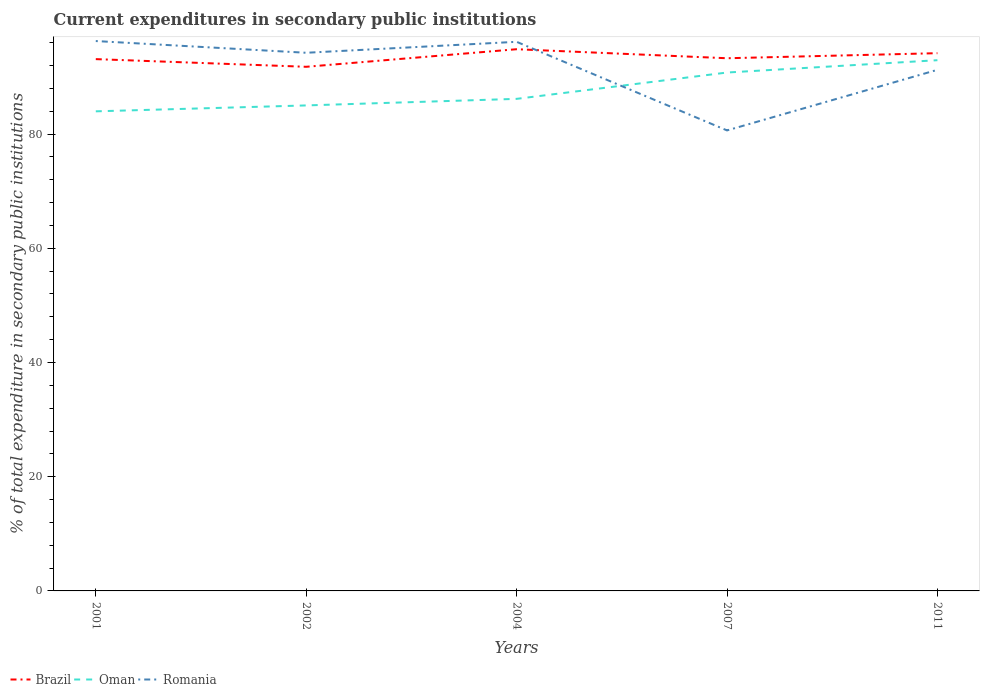How many different coloured lines are there?
Offer a very short reply. 3. Does the line corresponding to Romania intersect with the line corresponding to Brazil?
Your answer should be compact. Yes. Is the number of lines equal to the number of legend labels?
Keep it short and to the point. Yes. Across all years, what is the maximum current expenditures in secondary public institutions in Brazil?
Your answer should be very brief. 91.79. In which year was the current expenditures in secondary public institutions in Romania maximum?
Provide a short and direct response. 2007. What is the total current expenditures in secondary public institutions in Oman in the graph?
Provide a short and direct response. -1.03. What is the difference between the highest and the second highest current expenditures in secondary public institutions in Oman?
Offer a terse response. 8.96. What is the difference between the highest and the lowest current expenditures in secondary public institutions in Brazil?
Make the answer very short. 2. Is the current expenditures in secondary public institutions in Romania strictly greater than the current expenditures in secondary public institutions in Brazil over the years?
Keep it short and to the point. No. How many lines are there?
Offer a terse response. 3. How many years are there in the graph?
Keep it short and to the point. 5. Are the values on the major ticks of Y-axis written in scientific E-notation?
Keep it short and to the point. No. Where does the legend appear in the graph?
Keep it short and to the point. Bottom left. How are the legend labels stacked?
Provide a short and direct response. Horizontal. What is the title of the graph?
Make the answer very short. Current expenditures in secondary public institutions. Does "Guyana" appear as one of the legend labels in the graph?
Keep it short and to the point. No. What is the label or title of the Y-axis?
Your response must be concise. % of total expenditure in secondary public institutions. What is the % of total expenditure in secondary public institutions of Brazil in 2001?
Make the answer very short. 93.13. What is the % of total expenditure in secondary public institutions in Oman in 2001?
Provide a short and direct response. 83.99. What is the % of total expenditure in secondary public institutions of Romania in 2001?
Your answer should be compact. 96.3. What is the % of total expenditure in secondary public institutions in Brazil in 2002?
Provide a short and direct response. 91.79. What is the % of total expenditure in secondary public institutions in Oman in 2002?
Give a very brief answer. 85.02. What is the % of total expenditure in secondary public institutions of Romania in 2002?
Your response must be concise. 94.24. What is the % of total expenditure in secondary public institutions of Brazil in 2004?
Provide a short and direct response. 94.86. What is the % of total expenditure in secondary public institutions in Oman in 2004?
Provide a short and direct response. 86.17. What is the % of total expenditure in secondary public institutions in Romania in 2004?
Your response must be concise. 96.16. What is the % of total expenditure in secondary public institutions in Brazil in 2007?
Your response must be concise. 93.28. What is the % of total expenditure in secondary public institutions of Oman in 2007?
Offer a terse response. 90.78. What is the % of total expenditure in secondary public institutions in Romania in 2007?
Give a very brief answer. 80.65. What is the % of total expenditure in secondary public institutions in Brazil in 2011?
Keep it short and to the point. 94.17. What is the % of total expenditure in secondary public institutions of Oman in 2011?
Your answer should be compact. 92.94. What is the % of total expenditure in secondary public institutions in Romania in 2011?
Offer a terse response. 91.26. Across all years, what is the maximum % of total expenditure in secondary public institutions of Brazil?
Give a very brief answer. 94.86. Across all years, what is the maximum % of total expenditure in secondary public institutions in Oman?
Offer a terse response. 92.94. Across all years, what is the maximum % of total expenditure in secondary public institutions of Romania?
Your answer should be compact. 96.3. Across all years, what is the minimum % of total expenditure in secondary public institutions of Brazil?
Your answer should be very brief. 91.79. Across all years, what is the minimum % of total expenditure in secondary public institutions of Oman?
Offer a very short reply. 83.99. Across all years, what is the minimum % of total expenditure in secondary public institutions in Romania?
Ensure brevity in your answer.  80.65. What is the total % of total expenditure in secondary public institutions of Brazil in the graph?
Offer a terse response. 467.24. What is the total % of total expenditure in secondary public institutions of Oman in the graph?
Provide a short and direct response. 438.91. What is the total % of total expenditure in secondary public institutions of Romania in the graph?
Ensure brevity in your answer.  458.6. What is the difference between the % of total expenditure in secondary public institutions in Brazil in 2001 and that in 2002?
Provide a short and direct response. 1.34. What is the difference between the % of total expenditure in secondary public institutions in Oman in 2001 and that in 2002?
Keep it short and to the point. -1.03. What is the difference between the % of total expenditure in secondary public institutions in Romania in 2001 and that in 2002?
Keep it short and to the point. 2.05. What is the difference between the % of total expenditure in secondary public institutions of Brazil in 2001 and that in 2004?
Offer a terse response. -1.73. What is the difference between the % of total expenditure in secondary public institutions in Oman in 2001 and that in 2004?
Your response must be concise. -2.19. What is the difference between the % of total expenditure in secondary public institutions of Romania in 2001 and that in 2004?
Your answer should be compact. 0.13. What is the difference between the % of total expenditure in secondary public institutions of Brazil in 2001 and that in 2007?
Make the answer very short. -0.15. What is the difference between the % of total expenditure in secondary public institutions of Oman in 2001 and that in 2007?
Your response must be concise. -6.8. What is the difference between the % of total expenditure in secondary public institutions of Romania in 2001 and that in 2007?
Your response must be concise. 15.65. What is the difference between the % of total expenditure in secondary public institutions in Brazil in 2001 and that in 2011?
Your answer should be compact. -1.04. What is the difference between the % of total expenditure in secondary public institutions in Oman in 2001 and that in 2011?
Offer a terse response. -8.96. What is the difference between the % of total expenditure in secondary public institutions in Romania in 2001 and that in 2011?
Provide a short and direct response. 5.04. What is the difference between the % of total expenditure in secondary public institutions in Brazil in 2002 and that in 2004?
Offer a very short reply. -3.08. What is the difference between the % of total expenditure in secondary public institutions of Oman in 2002 and that in 2004?
Offer a very short reply. -1.15. What is the difference between the % of total expenditure in secondary public institutions in Romania in 2002 and that in 2004?
Your answer should be compact. -1.92. What is the difference between the % of total expenditure in secondary public institutions of Brazil in 2002 and that in 2007?
Give a very brief answer. -1.5. What is the difference between the % of total expenditure in secondary public institutions of Oman in 2002 and that in 2007?
Keep it short and to the point. -5.76. What is the difference between the % of total expenditure in secondary public institutions in Romania in 2002 and that in 2007?
Make the answer very short. 13.6. What is the difference between the % of total expenditure in secondary public institutions of Brazil in 2002 and that in 2011?
Your response must be concise. -2.38. What is the difference between the % of total expenditure in secondary public institutions in Oman in 2002 and that in 2011?
Provide a short and direct response. -7.92. What is the difference between the % of total expenditure in secondary public institutions in Romania in 2002 and that in 2011?
Your answer should be very brief. 2.99. What is the difference between the % of total expenditure in secondary public institutions of Brazil in 2004 and that in 2007?
Offer a very short reply. 1.58. What is the difference between the % of total expenditure in secondary public institutions of Oman in 2004 and that in 2007?
Keep it short and to the point. -4.61. What is the difference between the % of total expenditure in secondary public institutions in Romania in 2004 and that in 2007?
Provide a succinct answer. 15.52. What is the difference between the % of total expenditure in secondary public institutions of Brazil in 2004 and that in 2011?
Your answer should be compact. 0.69. What is the difference between the % of total expenditure in secondary public institutions of Oman in 2004 and that in 2011?
Your response must be concise. -6.77. What is the difference between the % of total expenditure in secondary public institutions of Romania in 2004 and that in 2011?
Make the answer very short. 4.91. What is the difference between the % of total expenditure in secondary public institutions in Brazil in 2007 and that in 2011?
Offer a terse response. -0.89. What is the difference between the % of total expenditure in secondary public institutions of Oman in 2007 and that in 2011?
Keep it short and to the point. -2.16. What is the difference between the % of total expenditure in secondary public institutions in Romania in 2007 and that in 2011?
Ensure brevity in your answer.  -10.61. What is the difference between the % of total expenditure in secondary public institutions of Brazil in 2001 and the % of total expenditure in secondary public institutions of Oman in 2002?
Offer a very short reply. 8.11. What is the difference between the % of total expenditure in secondary public institutions in Brazil in 2001 and the % of total expenditure in secondary public institutions in Romania in 2002?
Give a very brief answer. -1.11. What is the difference between the % of total expenditure in secondary public institutions in Oman in 2001 and the % of total expenditure in secondary public institutions in Romania in 2002?
Make the answer very short. -10.26. What is the difference between the % of total expenditure in secondary public institutions in Brazil in 2001 and the % of total expenditure in secondary public institutions in Oman in 2004?
Provide a succinct answer. 6.96. What is the difference between the % of total expenditure in secondary public institutions in Brazil in 2001 and the % of total expenditure in secondary public institutions in Romania in 2004?
Your answer should be compact. -3.03. What is the difference between the % of total expenditure in secondary public institutions in Oman in 2001 and the % of total expenditure in secondary public institutions in Romania in 2004?
Your answer should be compact. -12.18. What is the difference between the % of total expenditure in secondary public institutions of Brazil in 2001 and the % of total expenditure in secondary public institutions of Oman in 2007?
Ensure brevity in your answer.  2.35. What is the difference between the % of total expenditure in secondary public institutions in Brazil in 2001 and the % of total expenditure in secondary public institutions in Romania in 2007?
Your answer should be compact. 12.48. What is the difference between the % of total expenditure in secondary public institutions in Oman in 2001 and the % of total expenditure in secondary public institutions in Romania in 2007?
Ensure brevity in your answer.  3.34. What is the difference between the % of total expenditure in secondary public institutions of Brazil in 2001 and the % of total expenditure in secondary public institutions of Oman in 2011?
Your response must be concise. 0.19. What is the difference between the % of total expenditure in secondary public institutions in Brazil in 2001 and the % of total expenditure in secondary public institutions in Romania in 2011?
Provide a succinct answer. 1.88. What is the difference between the % of total expenditure in secondary public institutions in Oman in 2001 and the % of total expenditure in secondary public institutions in Romania in 2011?
Ensure brevity in your answer.  -7.27. What is the difference between the % of total expenditure in secondary public institutions in Brazil in 2002 and the % of total expenditure in secondary public institutions in Oman in 2004?
Your answer should be compact. 5.62. What is the difference between the % of total expenditure in secondary public institutions of Brazil in 2002 and the % of total expenditure in secondary public institutions of Romania in 2004?
Provide a short and direct response. -4.38. What is the difference between the % of total expenditure in secondary public institutions of Oman in 2002 and the % of total expenditure in secondary public institutions of Romania in 2004?
Make the answer very short. -11.14. What is the difference between the % of total expenditure in secondary public institutions of Brazil in 2002 and the % of total expenditure in secondary public institutions of Romania in 2007?
Offer a very short reply. 11.14. What is the difference between the % of total expenditure in secondary public institutions in Oman in 2002 and the % of total expenditure in secondary public institutions in Romania in 2007?
Your answer should be very brief. 4.38. What is the difference between the % of total expenditure in secondary public institutions of Brazil in 2002 and the % of total expenditure in secondary public institutions of Oman in 2011?
Offer a very short reply. -1.16. What is the difference between the % of total expenditure in secondary public institutions in Brazil in 2002 and the % of total expenditure in secondary public institutions in Romania in 2011?
Your answer should be very brief. 0.53. What is the difference between the % of total expenditure in secondary public institutions of Oman in 2002 and the % of total expenditure in secondary public institutions of Romania in 2011?
Your response must be concise. -6.23. What is the difference between the % of total expenditure in secondary public institutions of Brazil in 2004 and the % of total expenditure in secondary public institutions of Oman in 2007?
Provide a short and direct response. 4.08. What is the difference between the % of total expenditure in secondary public institutions of Brazil in 2004 and the % of total expenditure in secondary public institutions of Romania in 2007?
Your answer should be very brief. 14.22. What is the difference between the % of total expenditure in secondary public institutions in Oman in 2004 and the % of total expenditure in secondary public institutions in Romania in 2007?
Ensure brevity in your answer.  5.53. What is the difference between the % of total expenditure in secondary public institutions of Brazil in 2004 and the % of total expenditure in secondary public institutions of Oman in 2011?
Ensure brevity in your answer.  1.92. What is the difference between the % of total expenditure in secondary public institutions in Brazil in 2004 and the % of total expenditure in secondary public institutions in Romania in 2011?
Your response must be concise. 3.61. What is the difference between the % of total expenditure in secondary public institutions of Oman in 2004 and the % of total expenditure in secondary public institutions of Romania in 2011?
Offer a very short reply. -5.08. What is the difference between the % of total expenditure in secondary public institutions in Brazil in 2007 and the % of total expenditure in secondary public institutions in Oman in 2011?
Give a very brief answer. 0.34. What is the difference between the % of total expenditure in secondary public institutions in Brazil in 2007 and the % of total expenditure in secondary public institutions in Romania in 2011?
Ensure brevity in your answer.  2.03. What is the difference between the % of total expenditure in secondary public institutions in Oman in 2007 and the % of total expenditure in secondary public institutions in Romania in 2011?
Keep it short and to the point. -0.47. What is the average % of total expenditure in secondary public institutions of Brazil per year?
Keep it short and to the point. 93.45. What is the average % of total expenditure in secondary public institutions in Oman per year?
Offer a terse response. 87.78. What is the average % of total expenditure in secondary public institutions in Romania per year?
Give a very brief answer. 91.72. In the year 2001, what is the difference between the % of total expenditure in secondary public institutions in Brazil and % of total expenditure in secondary public institutions in Oman?
Keep it short and to the point. 9.14. In the year 2001, what is the difference between the % of total expenditure in secondary public institutions in Brazil and % of total expenditure in secondary public institutions in Romania?
Keep it short and to the point. -3.17. In the year 2001, what is the difference between the % of total expenditure in secondary public institutions in Oman and % of total expenditure in secondary public institutions in Romania?
Offer a very short reply. -12.31. In the year 2002, what is the difference between the % of total expenditure in secondary public institutions of Brazil and % of total expenditure in secondary public institutions of Oman?
Provide a short and direct response. 6.77. In the year 2002, what is the difference between the % of total expenditure in secondary public institutions in Brazil and % of total expenditure in secondary public institutions in Romania?
Offer a terse response. -2.46. In the year 2002, what is the difference between the % of total expenditure in secondary public institutions of Oman and % of total expenditure in secondary public institutions of Romania?
Provide a succinct answer. -9.22. In the year 2004, what is the difference between the % of total expenditure in secondary public institutions of Brazil and % of total expenditure in secondary public institutions of Oman?
Your answer should be very brief. 8.69. In the year 2004, what is the difference between the % of total expenditure in secondary public institutions of Brazil and % of total expenditure in secondary public institutions of Romania?
Offer a terse response. -1.3. In the year 2004, what is the difference between the % of total expenditure in secondary public institutions in Oman and % of total expenditure in secondary public institutions in Romania?
Provide a short and direct response. -9.99. In the year 2007, what is the difference between the % of total expenditure in secondary public institutions of Brazil and % of total expenditure in secondary public institutions of Oman?
Your response must be concise. 2.5. In the year 2007, what is the difference between the % of total expenditure in secondary public institutions in Brazil and % of total expenditure in secondary public institutions in Romania?
Give a very brief answer. 12.64. In the year 2007, what is the difference between the % of total expenditure in secondary public institutions of Oman and % of total expenditure in secondary public institutions of Romania?
Your answer should be very brief. 10.14. In the year 2011, what is the difference between the % of total expenditure in secondary public institutions in Brazil and % of total expenditure in secondary public institutions in Oman?
Your answer should be very brief. 1.23. In the year 2011, what is the difference between the % of total expenditure in secondary public institutions of Brazil and % of total expenditure in secondary public institutions of Romania?
Give a very brief answer. 2.92. In the year 2011, what is the difference between the % of total expenditure in secondary public institutions of Oman and % of total expenditure in secondary public institutions of Romania?
Keep it short and to the point. 1.69. What is the ratio of the % of total expenditure in secondary public institutions in Brazil in 2001 to that in 2002?
Ensure brevity in your answer.  1.01. What is the ratio of the % of total expenditure in secondary public institutions in Oman in 2001 to that in 2002?
Offer a very short reply. 0.99. What is the ratio of the % of total expenditure in secondary public institutions of Romania in 2001 to that in 2002?
Offer a terse response. 1.02. What is the ratio of the % of total expenditure in secondary public institutions in Brazil in 2001 to that in 2004?
Make the answer very short. 0.98. What is the ratio of the % of total expenditure in secondary public institutions in Oman in 2001 to that in 2004?
Your answer should be very brief. 0.97. What is the ratio of the % of total expenditure in secondary public institutions of Romania in 2001 to that in 2004?
Offer a very short reply. 1. What is the ratio of the % of total expenditure in secondary public institutions in Brazil in 2001 to that in 2007?
Give a very brief answer. 1. What is the ratio of the % of total expenditure in secondary public institutions in Oman in 2001 to that in 2007?
Offer a terse response. 0.93. What is the ratio of the % of total expenditure in secondary public institutions of Romania in 2001 to that in 2007?
Your answer should be compact. 1.19. What is the ratio of the % of total expenditure in secondary public institutions in Brazil in 2001 to that in 2011?
Ensure brevity in your answer.  0.99. What is the ratio of the % of total expenditure in secondary public institutions of Oman in 2001 to that in 2011?
Keep it short and to the point. 0.9. What is the ratio of the % of total expenditure in secondary public institutions of Romania in 2001 to that in 2011?
Ensure brevity in your answer.  1.06. What is the ratio of the % of total expenditure in secondary public institutions in Brazil in 2002 to that in 2004?
Provide a short and direct response. 0.97. What is the ratio of the % of total expenditure in secondary public institutions of Oman in 2002 to that in 2004?
Your response must be concise. 0.99. What is the ratio of the % of total expenditure in secondary public institutions in Brazil in 2002 to that in 2007?
Your answer should be compact. 0.98. What is the ratio of the % of total expenditure in secondary public institutions in Oman in 2002 to that in 2007?
Provide a succinct answer. 0.94. What is the ratio of the % of total expenditure in secondary public institutions in Romania in 2002 to that in 2007?
Your answer should be very brief. 1.17. What is the ratio of the % of total expenditure in secondary public institutions of Brazil in 2002 to that in 2011?
Your response must be concise. 0.97. What is the ratio of the % of total expenditure in secondary public institutions in Oman in 2002 to that in 2011?
Your answer should be very brief. 0.91. What is the ratio of the % of total expenditure in secondary public institutions in Romania in 2002 to that in 2011?
Provide a short and direct response. 1.03. What is the ratio of the % of total expenditure in secondary public institutions in Brazil in 2004 to that in 2007?
Ensure brevity in your answer.  1.02. What is the ratio of the % of total expenditure in secondary public institutions in Oman in 2004 to that in 2007?
Provide a short and direct response. 0.95. What is the ratio of the % of total expenditure in secondary public institutions of Romania in 2004 to that in 2007?
Make the answer very short. 1.19. What is the ratio of the % of total expenditure in secondary public institutions in Brazil in 2004 to that in 2011?
Offer a terse response. 1.01. What is the ratio of the % of total expenditure in secondary public institutions in Oman in 2004 to that in 2011?
Your answer should be compact. 0.93. What is the ratio of the % of total expenditure in secondary public institutions in Romania in 2004 to that in 2011?
Your answer should be compact. 1.05. What is the ratio of the % of total expenditure in secondary public institutions of Brazil in 2007 to that in 2011?
Provide a short and direct response. 0.99. What is the ratio of the % of total expenditure in secondary public institutions of Oman in 2007 to that in 2011?
Ensure brevity in your answer.  0.98. What is the ratio of the % of total expenditure in secondary public institutions of Romania in 2007 to that in 2011?
Your answer should be very brief. 0.88. What is the difference between the highest and the second highest % of total expenditure in secondary public institutions in Brazil?
Give a very brief answer. 0.69. What is the difference between the highest and the second highest % of total expenditure in secondary public institutions of Oman?
Make the answer very short. 2.16. What is the difference between the highest and the second highest % of total expenditure in secondary public institutions of Romania?
Offer a very short reply. 0.13. What is the difference between the highest and the lowest % of total expenditure in secondary public institutions in Brazil?
Make the answer very short. 3.08. What is the difference between the highest and the lowest % of total expenditure in secondary public institutions in Oman?
Make the answer very short. 8.96. What is the difference between the highest and the lowest % of total expenditure in secondary public institutions in Romania?
Your answer should be compact. 15.65. 